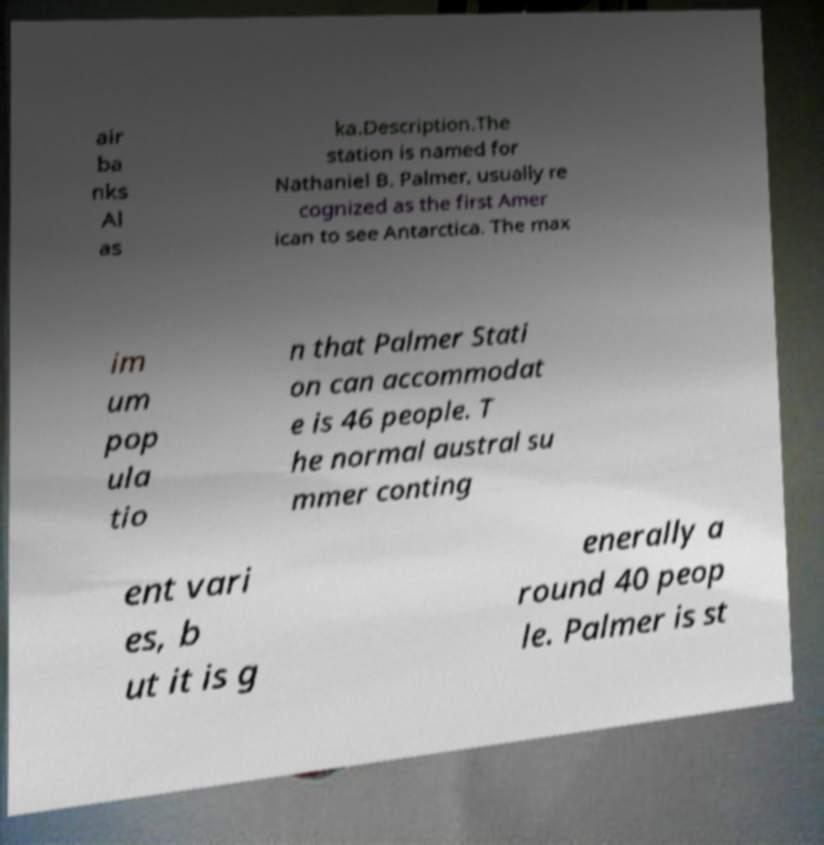Please identify and transcribe the text found in this image. air ba nks Al as ka.Description.The station is named for Nathaniel B. Palmer, usually re cognized as the first Amer ican to see Antarctica. The max im um pop ula tio n that Palmer Stati on can accommodat e is 46 people. T he normal austral su mmer conting ent vari es, b ut it is g enerally a round 40 peop le. Palmer is st 